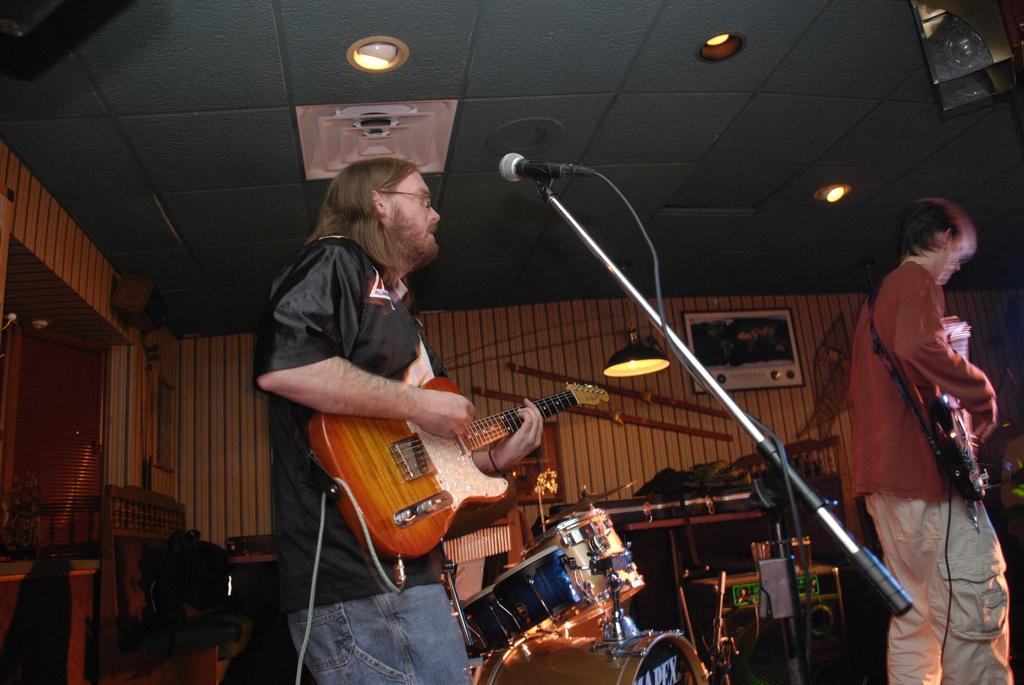What is the person in the image wearing? The person in the image is wearing a black shirt. What is the person doing while wearing the black shirt? The person is playing a guitar. What is in front of the person playing the guitar? There is a microphone in front of the person playing the guitar. Can you describe the other person in the image? There is another person playing a guitar in front of the person wearing a black shirt. What other musical instrument is visible in the image? There are drums beside the two guitar players. How many bombs can be seen in the image? There are no bombs present in the image. What type of trail can be seen behind the guitar players? There is no trail visible in the image. 